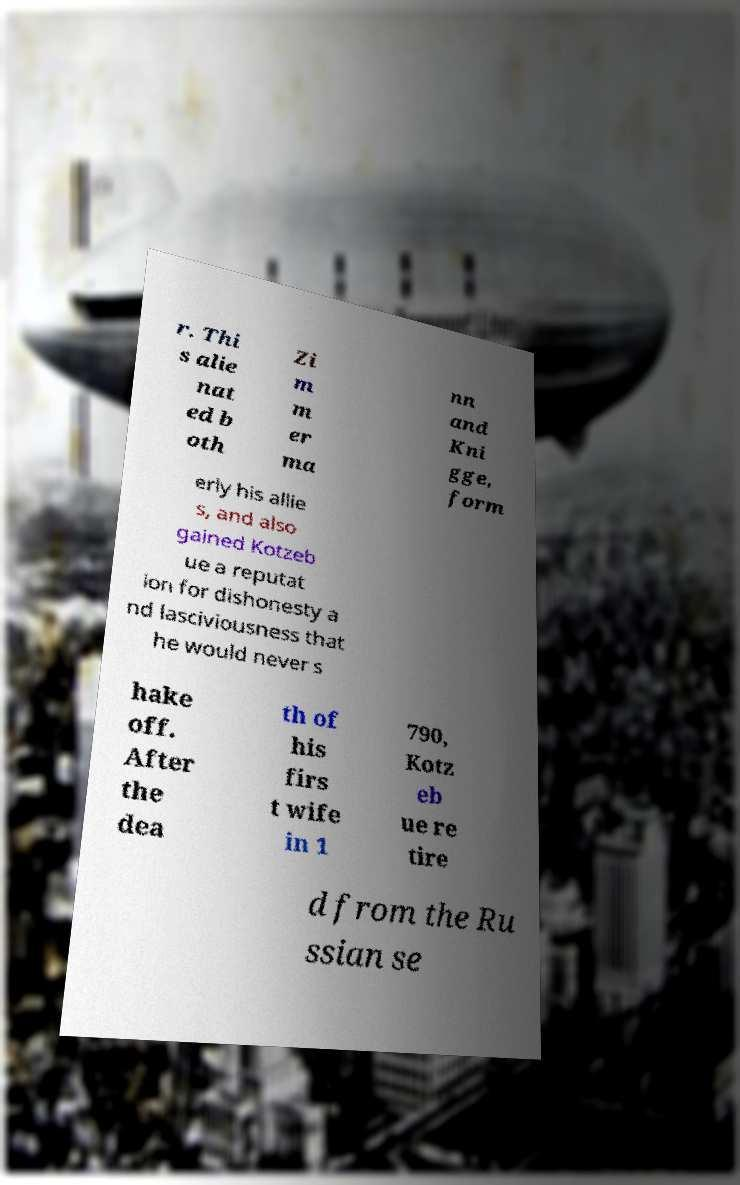What messages or text are displayed in this image? I need them in a readable, typed format. r. Thi s alie nat ed b oth Zi m m er ma nn and Kni gge, form erly his allie s, and also gained Kotzeb ue a reputat ion for dishonesty a nd lasciviousness that he would never s hake off. After the dea th of his firs t wife in 1 790, Kotz eb ue re tire d from the Ru ssian se 